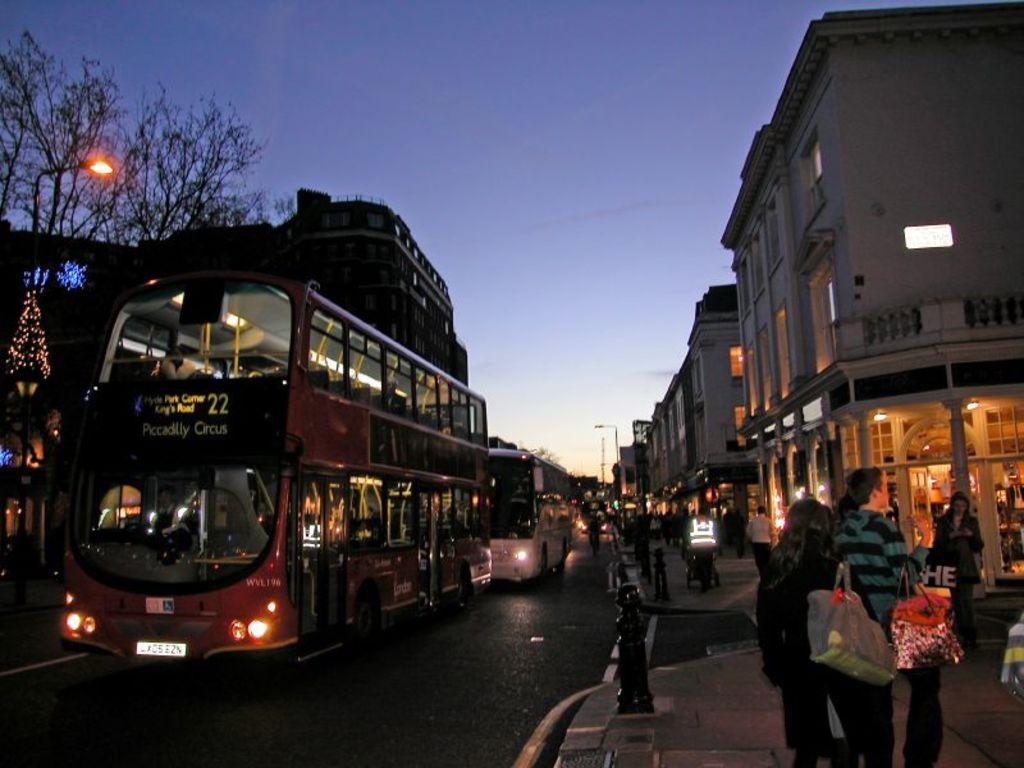What types of objects can be seen in the image? There are vehicles, trees, buildings, glass doors, and lights in the image. Can you describe the setting of the image? The image features a group of people in a location with trees, buildings, and glass doors. What is visible in the background of the image? The sky is visible in the background of the image. How many chairs can be seen in the image? There are no chairs present in the image. What color are the toes of the people in the image? There is no information about the color of the people's toes in the image. 